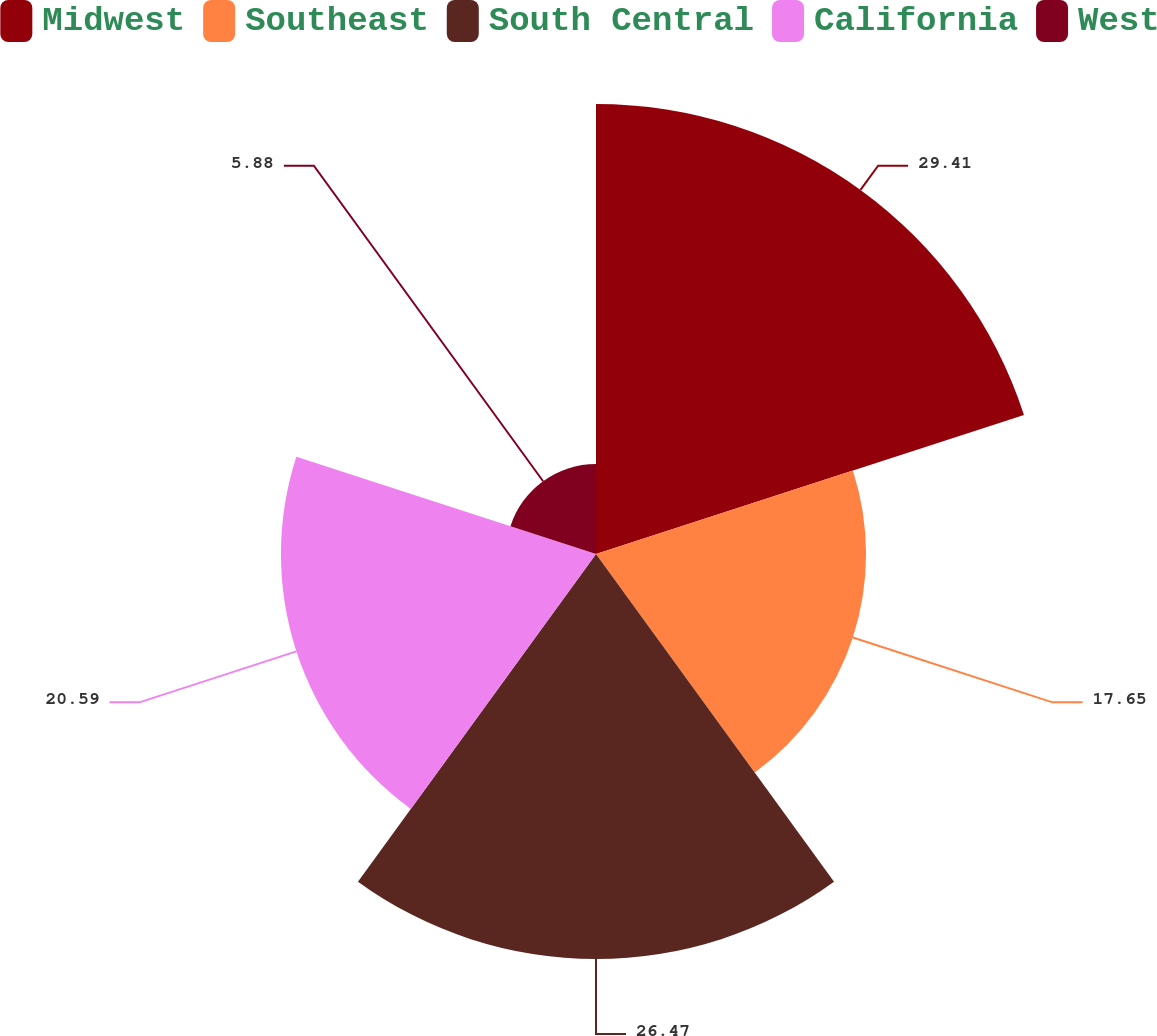Convert chart to OTSL. <chart><loc_0><loc_0><loc_500><loc_500><pie_chart><fcel>Midwest<fcel>Southeast<fcel>South Central<fcel>California<fcel>West<nl><fcel>29.41%<fcel>17.65%<fcel>26.47%<fcel>20.59%<fcel>5.88%<nl></chart> 